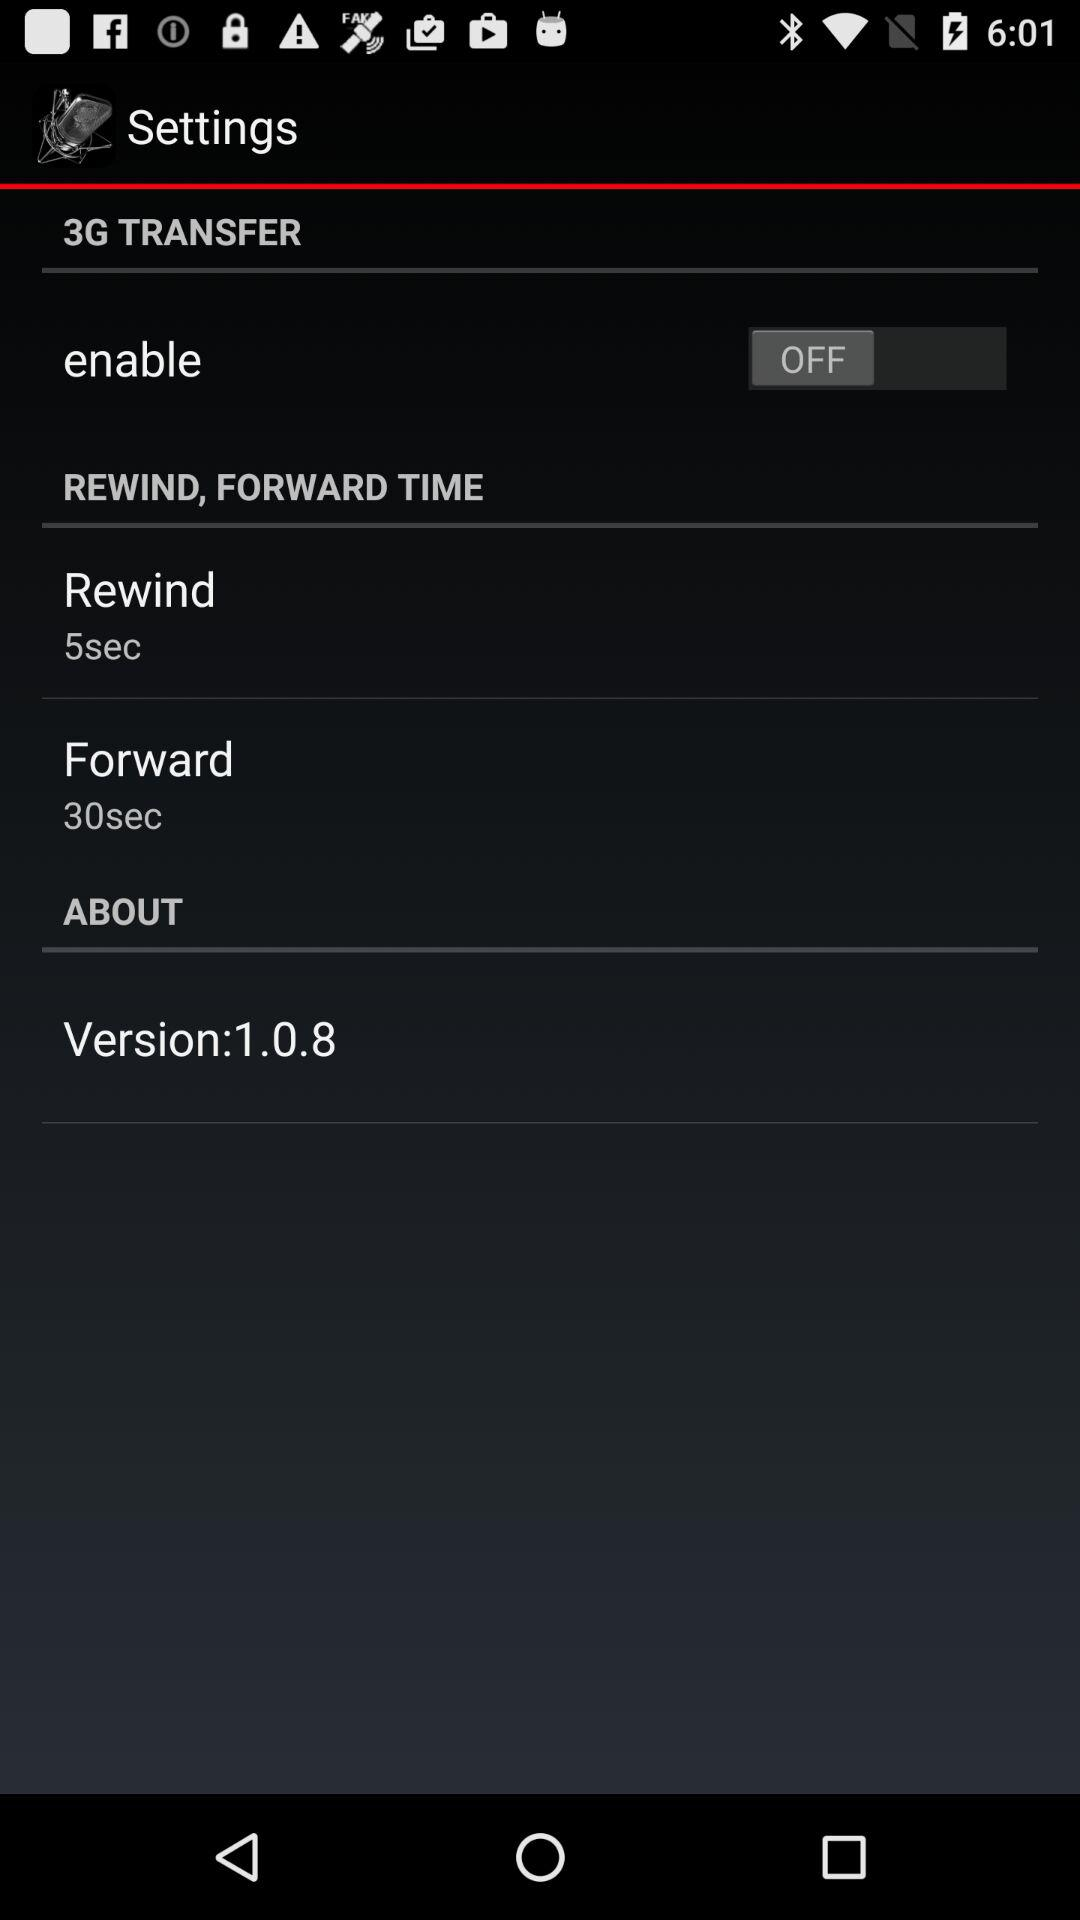How many more seconds are in the forward section than in the rewind section?
Answer the question using a single word or phrase. 25 